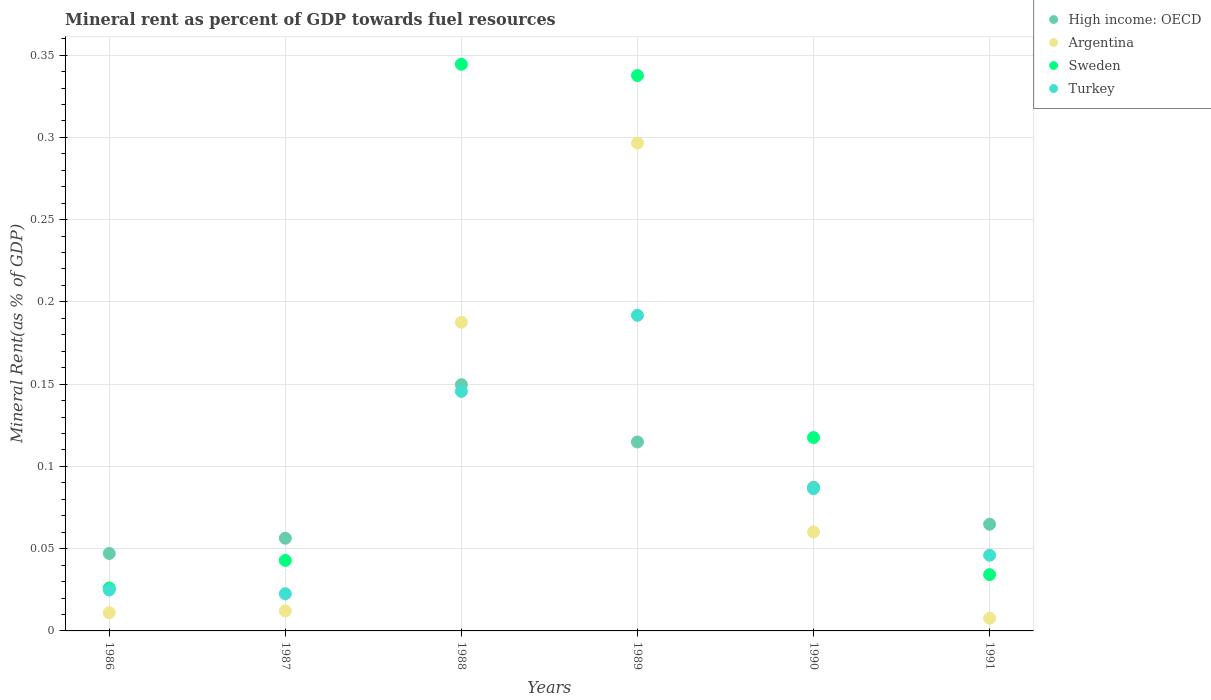What is the mineral rent in Turkey in 1990?
Your answer should be compact. 0.09. Across all years, what is the maximum mineral rent in Argentina?
Ensure brevity in your answer.  0.3. Across all years, what is the minimum mineral rent in Argentina?
Ensure brevity in your answer.  0.01. In which year was the mineral rent in High income: OECD maximum?
Offer a terse response. 1988. What is the total mineral rent in Argentina in the graph?
Ensure brevity in your answer.  0.58. What is the difference between the mineral rent in Sweden in 1990 and that in 1991?
Your answer should be compact. 0.08. What is the difference between the mineral rent in High income: OECD in 1990 and the mineral rent in Sweden in 1987?
Provide a succinct answer. 0.04. What is the average mineral rent in High income: OECD per year?
Keep it short and to the point. 0.09. In the year 1991, what is the difference between the mineral rent in Sweden and mineral rent in Turkey?
Make the answer very short. -0.01. In how many years, is the mineral rent in Argentina greater than 0.03 %?
Your answer should be compact. 3. What is the ratio of the mineral rent in Turkey in 1987 to that in 1989?
Offer a terse response. 0.12. Is the mineral rent in Argentina in 1986 less than that in 1989?
Offer a terse response. Yes. What is the difference between the highest and the second highest mineral rent in Turkey?
Make the answer very short. 0.05. What is the difference between the highest and the lowest mineral rent in Turkey?
Your answer should be compact. 0.17. In how many years, is the mineral rent in High income: OECD greater than the average mineral rent in High income: OECD taken over all years?
Provide a succinct answer. 3. Is the sum of the mineral rent in Turkey in 1987 and 1990 greater than the maximum mineral rent in High income: OECD across all years?
Your response must be concise. No. Is it the case that in every year, the sum of the mineral rent in Argentina and mineral rent in Turkey  is greater than the mineral rent in Sweden?
Provide a short and direct response. No. Does the mineral rent in High income: OECD monotonically increase over the years?
Offer a terse response. No. Is the mineral rent in High income: OECD strictly greater than the mineral rent in Sweden over the years?
Offer a very short reply. No. How many years are there in the graph?
Your answer should be compact. 6. Does the graph contain any zero values?
Provide a short and direct response. No. Does the graph contain grids?
Your answer should be compact. Yes. How are the legend labels stacked?
Your answer should be compact. Vertical. What is the title of the graph?
Provide a short and direct response. Mineral rent as percent of GDP towards fuel resources. What is the label or title of the X-axis?
Ensure brevity in your answer.  Years. What is the label or title of the Y-axis?
Provide a succinct answer. Mineral Rent(as % of GDP). What is the Mineral Rent(as % of GDP) of High income: OECD in 1986?
Your response must be concise. 0.05. What is the Mineral Rent(as % of GDP) of Argentina in 1986?
Make the answer very short. 0.01. What is the Mineral Rent(as % of GDP) in Sweden in 1986?
Give a very brief answer. 0.03. What is the Mineral Rent(as % of GDP) of Turkey in 1986?
Your answer should be compact. 0.02. What is the Mineral Rent(as % of GDP) in High income: OECD in 1987?
Your answer should be very brief. 0.06. What is the Mineral Rent(as % of GDP) of Argentina in 1987?
Make the answer very short. 0.01. What is the Mineral Rent(as % of GDP) in Sweden in 1987?
Provide a succinct answer. 0.04. What is the Mineral Rent(as % of GDP) of Turkey in 1987?
Offer a terse response. 0.02. What is the Mineral Rent(as % of GDP) in High income: OECD in 1988?
Ensure brevity in your answer.  0.15. What is the Mineral Rent(as % of GDP) of Argentina in 1988?
Give a very brief answer. 0.19. What is the Mineral Rent(as % of GDP) of Sweden in 1988?
Offer a very short reply. 0.34. What is the Mineral Rent(as % of GDP) in Turkey in 1988?
Give a very brief answer. 0.15. What is the Mineral Rent(as % of GDP) of High income: OECD in 1989?
Your response must be concise. 0.11. What is the Mineral Rent(as % of GDP) of Argentina in 1989?
Provide a short and direct response. 0.3. What is the Mineral Rent(as % of GDP) of Sweden in 1989?
Ensure brevity in your answer.  0.34. What is the Mineral Rent(as % of GDP) in Turkey in 1989?
Provide a succinct answer. 0.19. What is the Mineral Rent(as % of GDP) of High income: OECD in 1990?
Your response must be concise. 0.09. What is the Mineral Rent(as % of GDP) of Argentina in 1990?
Keep it short and to the point. 0.06. What is the Mineral Rent(as % of GDP) of Sweden in 1990?
Your answer should be compact. 0.12. What is the Mineral Rent(as % of GDP) in Turkey in 1990?
Provide a succinct answer. 0.09. What is the Mineral Rent(as % of GDP) in High income: OECD in 1991?
Keep it short and to the point. 0.06. What is the Mineral Rent(as % of GDP) of Argentina in 1991?
Your answer should be very brief. 0.01. What is the Mineral Rent(as % of GDP) of Sweden in 1991?
Provide a succinct answer. 0.03. What is the Mineral Rent(as % of GDP) in Turkey in 1991?
Your response must be concise. 0.05. Across all years, what is the maximum Mineral Rent(as % of GDP) in High income: OECD?
Make the answer very short. 0.15. Across all years, what is the maximum Mineral Rent(as % of GDP) of Argentina?
Make the answer very short. 0.3. Across all years, what is the maximum Mineral Rent(as % of GDP) in Sweden?
Your answer should be compact. 0.34. Across all years, what is the maximum Mineral Rent(as % of GDP) in Turkey?
Offer a terse response. 0.19. Across all years, what is the minimum Mineral Rent(as % of GDP) of High income: OECD?
Offer a very short reply. 0.05. Across all years, what is the minimum Mineral Rent(as % of GDP) in Argentina?
Provide a succinct answer. 0.01. Across all years, what is the minimum Mineral Rent(as % of GDP) in Sweden?
Give a very brief answer. 0.03. Across all years, what is the minimum Mineral Rent(as % of GDP) in Turkey?
Make the answer very short. 0.02. What is the total Mineral Rent(as % of GDP) in High income: OECD in the graph?
Provide a short and direct response. 0.52. What is the total Mineral Rent(as % of GDP) of Argentina in the graph?
Give a very brief answer. 0.58. What is the total Mineral Rent(as % of GDP) of Sweden in the graph?
Your answer should be compact. 0.9. What is the total Mineral Rent(as % of GDP) in Turkey in the graph?
Your answer should be very brief. 0.52. What is the difference between the Mineral Rent(as % of GDP) in High income: OECD in 1986 and that in 1987?
Offer a terse response. -0.01. What is the difference between the Mineral Rent(as % of GDP) of Argentina in 1986 and that in 1987?
Your response must be concise. -0. What is the difference between the Mineral Rent(as % of GDP) in Sweden in 1986 and that in 1987?
Your response must be concise. -0.02. What is the difference between the Mineral Rent(as % of GDP) in Turkey in 1986 and that in 1987?
Offer a very short reply. 0. What is the difference between the Mineral Rent(as % of GDP) in High income: OECD in 1986 and that in 1988?
Your answer should be compact. -0.1. What is the difference between the Mineral Rent(as % of GDP) in Argentina in 1986 and that in 1988?
Give a very brief answer. -0.18. What is the difference between the Mineral Rent(as % of GDP) in Sweden in 1986 and that in 1988?
Offer a terse response. -0.32. What is the difference between the Mineral Rent(as % of GDP) in Turkey in 1986 and that in 1988?
Make the answer very short. -0.12. What is the difference between the Mineral Rent(as % of GDP) of High income: OECD in 1986 and that in 1989?
Provide a short and direct response. -0.07. What is the difference between the Mineral Rent(as % of GDP) in Argentina in 1986 and that in 1989?
Make the answer very short. -0.29. What is the difference between the Mineral Rent(as % of GDP) of Sweden in 1986 and that in 1989?
Your answer should be compact. -0.31. What is the difference between the Mineral Rent(as % of GDP) in Turkey in 1986 and that in 1989?
Provide a short and direct response. -0.17. What is the difference between the Mineral Rent(as % of GDP) in High income: OECD in 1986 and that in 1990?
Ensure brevity in your answer.  -0.04. What is the difference between the Mineral Rent(as % of GDP) in Argentina in 1986 and that in 1990?
Offer a very short reply. -0.05. What is the difference between the Mineral Rent(as % of GDP) of Sweden in 1986 and that in 1990?
Ensure brevity in your answer.  -0.09. What is the difference between the Mineral Rent(as % of GDP) of Turkey in 1986 and that in 1990?
Offer a very short reply. -0.06. What is the difference between the Mineral Rent(as % of GDP) of High income: OECD in 1986 and that in 1991?
Keep it short and to the point. -0.02. What is the difference between the Mineral Rent(as % of GDP) of Argentina in 1986 and that in 1991?
Your answer should be very brief. 0. What is the difference between the Mineral Rent(as % of GDP) in Sweden in 1986 and that in 1991?
Your answer should be compact. -0.01. What is the difference between the Mineral Rent(as % of GDP) in Turkey in 1986 and that in 1991?
Offer a very short reply. -0.02. What is the difference between the Mineral Rent(as % of GDP) in High income: OECD in 1987 and that in 1988?
Offer a terse response. -0.09. What is the difference between the Mineral Rent(as % of GDP) in Argentina in 1987 and that in 1988?
Ensure brevity in your answer.  -0.18. What is the difference between the Mineral Rent(as % of GDP) of Sweden in 1987 and that in 1988?
Offer a very short reply. -0.3. What is the difference between the Mineral Rent(as % of GDP) in Turkey in 1987 and that in 1988?
Provide a short and direct response. -0.12. What is the difference between the Mineral Rent(as % of GDP) in High income: OECD in 1987 and that in 1989?
Provide a succinct answer. -0.06. What is the difference between the Mineral Rent(as % of GDP) in Argentina in 1987 and that in 1989?
Provide a short and direct response. -0.28. What is the difference between the Mineral Rent(as % of GDP) of Sweden in 1987 and that in 1989?
Your answer should be very brief. -0.29. What is the difference between the Mineral Rent(as % of GDP) of Turkey in 1987 and that in 1989?
Give a very brief answer. -0.17. What is the difference between the Mineral Rent(as % of GDP) in High income: OECD in 1987 and that in 1990?
Make the answer very short. -0.03. What is the difference between the Mineral Rent(as % of GDP) of Argentina in 1987 and that in 1990?
Your answer should be compact. -0.05. What is the difference between the Mineral Rent(as % of GDP) of Sweden in 1987 and that in 1990?
Your answer should be very brief. -0.07. What is the difference between the Mineral Rent(as % of GDP) in Turkey in 1987 and that in 1990?
Make the answer very short. -0.06. What is the difference between the Mineral Rent(as % of GDP) in High income: OECD in 1987 and that in 1991?
Provide a short and direct response. -0.01. What is the difference between the Mineral Rent(as % of GDP) of Argentina in 1987 and that in 1991?
Your answer should be very brief. 0. What is the difference between the Mineral Rent(as % of GDP) of Sweden in 1987 and that in 1991?
Make the answer very short. 0.01. What is the difference between the Mineral Rent(as % of GDP) of Turkey in 1987 and that in 1991?
Your answer should be very brief. -0.02. What is the difference between the Mineral Rent(as % of GDP) in High income: OECD in 1988 and that in 1989?
Provide a succinct answer. 0.03. What is the difference between the Mineral Rent(as % of GDP) of Argentina in 1988 and that in 1989?
Give a very brief answer. -0.11. What is the difference between the Mineral Rent(as % of GDP) in Sweden in 1988 and that in 1989?
Provide a succinct answer. 0.01. What is the difference between the Mineral Rent(as % of GDP) in Turkey in 1988 and that in 1989?
Your answer should be compact. -0.05. What is the difference between the Mineral Rent(as % of GDP) in High income: OECD in 1988 and that in 1990?
Offer a very short reply. 0.06. What is the difference between the Mineral Rent(as % of GDP) of Argentina in 1988 and that in 1990?
Your answer should be very brief. 0.13. What is the difference between the Mineral Rent(as % of GDP) in Sweden in 1988 and that in 1990?
Offer a terse response. 0.23. What is the difference between the Mineral Rent(as % of GDP) in Turkey in 1988 and that in 1990?
Provide a succinct answer. 0.06. What is the difference between the Mineral Rent(as % of GDP) in High income: OECD in 1988 and that in 1991?
Your answer should be very brief. 0.08. What is the difference between the Mineral Rent(as % of GDP) of Argentina in 1988 and that in 1991?
Your response must be concise. 0.18. What is the difference between the Mineral Rent(as % of GDP) in Sweden in 1988 and that in 1991?
Offer a very short reply. 0.31. What is the difference between the Mineral Rent(as % of GDP) of Turkey in 1988 and that in 1991?
Offer a terse response. 0.1. What is the difference between the Mineral Rent(as % of GDP) in High income: OECD in 1989 and that in 1990?
Ensure brevity in your answer.  0.03. What is the difference between the Mineral Rent(as % of GDP) of Argentina in 1989 and that in 1990?
Your answer should be very brief. 0.24. What is the difference between the Mineral Rent(as % of GDP) of Sweden in 1989 and that in 1990?
Give a very brief answer. 0.22. What is the difference between the Mineral Rent(as % of GDP) in Turkey in 1989 and that in 1990?
Offer a very short reply. 0.11. What is the difference between the Mineral Rent(as % of GDP) of High income: OECD in 1989 and that in 1991?
Provide a short and direct response. 0.05. What is the difference between the Mineral Rent(as % of GDP) of Argentina in 1989 and that in 1991?
Provide a succinct answer. 0.29. What is the difference between the Mineral Rent(as % of GDP) in Sweden in 1989 and that in 1991?
Offer a terse response. 0.3. What is the difference between the Mineral Rent(as % of GDP) of Turkey in 1989 and that in 1991?
Make the answer very short. 0.15. What is the difference between the Mineral Rent(as % of GDP) in High income: OECD in 1990 and that in 1991?
Keep it short and to the point. 0.02. What is the difference between the Mineral Rent(as % of GDP) in Argentina in 1990 and that in 1991?
Offer a terse response. 0.05. What is the difference between the Mineral Rent(as % of GDP) of Sweden in 1990 and that in 1991?
Ensure brevity in your answer.  0.08. What is the difference between the Mineral Rent(as % of GDP) in Turkey in 1990 and that in 1991?
Give a very brief answer. 0.04. What is the difference between the Mineral Rent(as % of GDP) in High income: OECD in 1986 and the Mineral Rent(as % of GDP) in Argentina in 1987?
Offer a terse response. 0.03. What is the difference between the Mineral Rent(as % of GDP) of High income: OECD in 1986 and the Mineral Rent(as % of GDP) of Sweden in 1987?
Give a very brief answer. 0. What is the difference between the Mineral Rent(as % of GDP) of High income: OECD in 1986 and the Mineral Rent(as % of GDP) of Turkey in 1987?
Keep it short and to the point. 0.02. What is the difference between the Mineral Rent(as % of GDP) of Argentina in 1986 and the Mineral Rent(as % of GDP) of Sweden in 1987?
Your response must be concise. -0.03. What is the difference between the Mineral Rent(as % of GDP) in Argentina in 1986 and the Mineral Rent(as % of GDP) in Turkey in 1987?
Give a very brief answer. -0.01. What is the difference between the Mineral Rent(as % of GDP) in Sweden in 1986 and the Mineral Rent(as % of GDP) in Turkey in 1987?
Your answer should be very brief. 0. What is the difference between the Mineral Rent(as % of GDP) in High income: OECD in 1986 and the Mineral Rent(as % of GDP) in Argentina in 1988?
Make the answer very short. -0.14. What is the difference between the Mineral Rent(as % of GDP) in High income: OECD in 1986 and the Mineral Rent(as % of GDP) in Sweden in 1988?
Your answer should be compact. -0.3. What is the difference between the Mineral Rent(as % of GDP) in High income: OECD in 1986 and the Mineral Rent(as % of GDP) in Turkey in 1988?
Your answer should be compact. -0.1. What is the difference between the Mineral Rent(as % of GDP) in Argentina in 1986 and the Mineral Rent(as % of GDP) in Sweden in 1988?
Your response must be concise. -0.33. What is the difference between the Mineral Rent(as % of GDP) in Argentina in 1986 and the Mineral Rent(as % of GDP) in Turkey in 1988?
Provide a short and direct response. -0.13. What is the difference between the Mineral Rent(as % of GDP) in Sweden in 1986 and the Mineral Rent(as % of GDP) in Turkey in 1988?
Give a very brief answer. -0.12. What is the difference between the Mineral Rent(as % of GDP) in High income: OECD in 1986 and the Mineral Rent(as % of GDP) in Argentina in 1989?
Offer a very short reply. -0.25. What is the difference between the Mineral Rent(as % of GDP) of High income: OECD in 1986 and the Mineral Rent(as % of GDP) of Sweden in 1989?
Provide a succinct answer. -0.29. What is the difference between the Mineral Rent(as % of GDP) in High income: OECD in 1986 and the Mineral Rent(as % of GDP) in Turkey in 1989?
Give a very brief answer. -0.14. What is the difference between the Mineral Rent(as % of GDP) in Argentina in 1986 and the Mineral Rent(as % of GDP) in Sweden in 1989?
Your answer should be very brief. -0.33. What is the difference between the Mineral Rent(as % of GDP) in Argentina in 1986 and the Mineral Rent(as % of GDP) in Turkey in 1989?
Keep it short and to the point. -0.18. What is the difference between the Mineral Rent(as % of GDP) of Sweden in 1986 and the Mineral Rent(as % of GDP) of Turkey in 1989?
Keep it short and to the point. -0.17. What is the difference between the Mineral Rent(as % of GDP) in High income: OECD in 1986 and the Mineral Rent(as % of GDP) in Argentina in 1990?
Ensure brevity in your answer.  -0.01. What is the difference between the Mineral Rent(as % of GDP) of High income: OECD in 1986 and the Mineral Rent(as % of GDP) of Sweden in 1990?
Give a very brief answer. -0.07. What is the difference between the Mineral Rent(as % of GDP) of High income: OECD in 1986 and the Mineral Rent(as % of GDP) of Turkey in 1990?
Your response must be concise. -0.04. What is the difference between the Mineral Rent(as % of GDP) in Argentina in 1986 and the Mineral Rent(as % of GDP) in Sweden in 1990?
Your response must be concise. -0.11. What is the difference between the Mineral Rent(as % of GDP) in Argentina in 1986 and the Mineral Rent(as % of GDP) in Turkey in 1990?
Make the answer very short. -0.08. What is the difference between the Mineral Rent(as % of GDP) of Sweden in 1986 and the Mineral Rent(as % of GDP) of Turkey in 1990?
Offer a very short reply. -0.06. What is the difference between the Mineral Rent(as % of GDP) of High income: OECD in 1986 and the Mineral Rent(as % of GDP) of Argentina in 1991?
Give a very brief answer. 0.04. What is the difference between the Mineral Rent(as % of GDP) in High income: OECD in 1986 and the Mineral Rent(as % of GDP) in Sweden in 1991?
Offer a very short reply. 0.01. What is the difference between the Mineral Rent(as % of GDP) of High income: OECD in 1986 and the Mineral Rent(as % of GDP) of Turkey in 1991?
Ensure brevity in your answer.  0. What is the difference between the Mineral Rent(as % of GDP) of Argentina in 1986 and the Mineral Rent(as % of GDP) of Sweden in 1991?
Provide a succinct answer. -0.02. What is the difference between the Mineral Rent(as % of GDP) of Argentina in 1986 and the Mineral Rent(as % of GDP) of Turkey in 1991?
Keep it short and to the point. -0.03. What is the difference between the Mineral Rent(as % of GDP) of Sweden in 1986 and the Mineral Rent(as % of GDP) of Turkey in 1991?
Make the answer very short. -0.02. What is the difference between the Mineral Rent(as % of GDP) of High income: OECD in 1987 and the Mineral Rent(as % of GDP) of Argentina in 1988?
Your response must be concise. -0.13. What is the difference between the Mineral Rent(as % of GDP) of High income: OECD in 1987 and the Mineral Rent(as % of GDP) of Sweden in 1988?
Your answer should be compact. -0.29. What is the difference between the Mineral Rent(as % of GDP) in High income: OECD in 1987 and the Mineral Rent(as % of GDP) in Turkey in 1988?
Your response must be concise. -0.09. What is the difference between the Mineral Rent(as % of GDP) in Argentina in 1987 and the Mineral Rent(as % of GDP) in Sweden in 1988?
Offer a terse response. -0.33. What is the difference between the Mineral Rent(as % of GDP) in Argentina in 1987 and the Mineral Rent(as % of GDP) in Turkey in 1988?
Offer a terse response. -0.13. What is the difference between the Mineral Rent(as % of GDP) in Sweden in 1987 and the Mineral Rent(as % of GDP) in Turkey in 1988?
Provide a succinct answer. -0.1. What is the difference between the Mineral Rent(as % of GDP) in High income: OECD in 1987 and the Mineral Rent(as % of GDP) in Argentina in 1989?
Keep it short and to the point. -0.24. What is the difference between the Mineral Rent(as % of GDP) in High income: OECD in 1987 and the Mineral Rent(as % of GDP) in Sweden in 1989?
Give a very brief answer. -0.28. What is the difference between the Mineral Rent(as % of GDP) of High income: OECD in 1987 and the Mineral Rent(as % of GDP) of Turkey in 1989?
Keep it short and to the point. -0.14. What is the difference between the Mineral Rent(as % of GDP) in Argentina in 1987 and the Mineral Rent(as % of GDP) in Sweden in 1989?
Make the answer very short. -0.33. What is the difference between the Mineral Rent(as % of GDP) of Argentina in 1987 and the Mineral Rent(as % of GDP) of Turkey in 1989?
Your response must be concise. -0.18. What is the difference between the Mineral Rent(as % of GDP) of Sweden in 1987 and the Mineral Rent(as % of GDP) of Turkey in 1989?
Your answer should be very brief. -0.15. What is the difference between the Mineral Rent(as % of GDP) of High income: OECD in 1987 and the Mineral Rent(as % of GDP) of Argentina in 1990?
Ensure brevity in your answer.  -0. What is the difference between the Mineral Rent(as % of GDP) of High income: OECD in 1987 and the Mineral Rent(as % of GDP) of Sweden in 1990?
Your response must be concise. -0.06. What is the difference between the Mineral Rent(as % of GDP) in High income: OECD in 1987 and the Mineral Rent(as % of GDP) in Turkey in 1990?
Give a very brief answer. -0.03. What is the difference between the Mineral Rent(as % of GDP) in Argentina in 1987 and the Mineral Rent(as % of GDP) in Sweden in 1990?
Give a very brief answer. -0.11. What is the difference between the Mineral Rent(as % of GDP) of Argentina in 1987 and the Mineral Rent(as % of GDP) of Turkey in 1990?
Your answer should be compact. -0.07. What is the difference between the Mineral Rent(as % of GDP) in Sweden in 1987 and the Mineral Rent(as % of GDP) in Turkey in 1990?
Ensure brevity in your answer.  -0.04. What is the difference between the Mineral Rent(as % of GDP) of High income: OECD in 1987 and the Mineral Rent(as % of GDP) of Argentina in 1991?
Your response must be concise. 0.05. What is the difference between the Mineral Rent(as % of GDP) of High income: OECD in 1987 and the Mineral Rent(as % of GDP) of Sweden in 1991?
Offer a very short reply. 0.02. What is the difference between the Mineral Rent(as % of GDP) of High income: OECD in 1987 and the Mineral Rent(as % of GDP) of Turkey in 1991?
Your response must be concise. 0.01. What is the difference between the Mineral Rent(as % of GDP) of Argentina in 1987 and the Mineral Rent(as % of GDP) of Sweden in 1991?
Keep it short and to the point. -0.02. What is the difference between the Mineral Rent(as % of GDP) of Argentina in 1987 and the Mineral Rent(as % of GDP) of Turkey in 1991?
Your response must be concise. -0.03. What is the difference between the Mineral Rent(as % of GDP) in Sweden in 1987 and the Mineral Rent(as % of GDP) in Turkey in 1991?
Provide a short and direct response. -0. What is the difference between the Mineral Rent(as % of GDP) in High income: OECD in 1988 and the Mineral Rent(as % of GDP) in Argentina in 1989?
Offer a terse response. -0.15. What is the difference between the Mineral Rent(as % of GDP) in High income: OECD in 1988 and the Mineral Rent(as % of GDP) in Sweden in 1989?
Your answer should be very brief. -0.19. What is the difference between the Mineral Rent(as % of GDP) of High income: OECD in 1988 and the Mineral Rent(as % of GDP) of Turkey in 1989?
Your response must be concise. -0.04. What is the difference between the Mineral Rent(as % of GDP) in Argentina in 1988 and the Mineral Rent(as % of GDP) in Turkey in 1989?
Your answer should be very brief. -0. What is the difference between the Mineral Rent(as % of GDP) of Sweden in 1988 and the Mineral Rent(as % of GDP) of Turkey in 1989?
Offer a very short reply. 0.15. What is the difference between the Mineral Rent(as % of GDP) in High income: OECD in 1988 and the Mineral Rent(as % of GDP) in Argentina in 1990?
Your answer should be very brief. 0.09. What is the difference between the Mineral Rent(as % of GDP) in High income: OECD in 1988 and the Mineral Rent(as % of GDP) in Sweden in 1990?
Ensure brevity in your answer.  0.03. What is the difference between the Mineral Rent(as % of GDP) of High income: OECD in 1988 and the Mineral Rent(as % of GDP) of Turkey in 1990?
Make the answer very short. 0.06. What is the difference between the Mineral Rent(as % of GDP) of Argentina in 1988 and the Mineral Rent(as % of GDP) of Sweden in 1990?
Provide a succinct answer. 0.07. What is the difference between the Mineral Rent(as % of GDP) of Argentina in 1988 and the Mineral Rent(as % of GDP) of Turkey in 1990?
Your response must be concise. 0.1. What is the difference between the Mineral Rent(as % of GDP) in Sweden in 1988 and the Mineral Rent(as % of GDP) in Turkey in 1990?
Ensure brevity in your answer.  0.26. What is the difference between the Mineral Rent(as % of GDP) in High income: OECD in 1988 and the Mineral Rent(as % of GDP) in Argentina in 1991?
Your answer should be compact. 0.14. What is the difference between the Mineral Rent(as % of GDP) of High income: OECD in 1988 and the Mineral Rent(as % of GDP) of Sweden in 1991?
Offer a very short reply. 0.12. What is the difference between the Mineral Rent(as % of GDP) of High income: OECD in 1988 and the Mineral Rent(as % of GDP) of Turkey in 1991?
Your response must be concise. 0.1. What is the difference between the Mineral Rent(as % of GDP) of Argentina in 1988 and the Mineral Rent(as % of GDP) of Sweden in 1991?
Provide a succinct answer. 0.15. What is the difference between the Mineral Rent(as % of GDP) of Argentina in 1988 and the Mineral Rent(as % of GDP) of Turkey in 1991?
Provide a short and direct response. 0.14. What is the difference between the Mineral Rent(as % of GDP) in Sweden in 1988 and the Mineral Rent(as % of GDP) in Turkey in 1991?
Your response must be concise. 0.3. What is the difference between the Mineral Rent(as % of GDP) in High income: OECD in 1989 and the Mineral Rent(as % of GDP) in Argentina in 1990?
Offer a terse response. 0.05. What is the difference between the Mineral Rent(as % of GDP) of High income: OECD in 1989 and the Mineral Rent(as % of GDP) of Sweden in 1990?
Provide a succinct answer. -0. What is the difference between the Mineral Rent(as % of GDP) in High income: OECD in 1989 and the Mineral Rent(as % of GDP) in Turkey in 1990?
Offer a very short reply. 0.03. What is the difference between the Mineral Rent(as % of GDP) of Argentina in 1989 and the Mineral Rent(as % of GDP) of Sweden in 1990?
Offer a terse response. 0.18. What is the difference between the Mineral Rent(as % of GDP) of Argentina in 1989 and the Mineral Rent(as % of GDP) of Turkey in 1990?
Your answer should be very brief. 0.21. What is the difference between the Mineral Rent(as % of GDP) in Sweden in 1989 and the Mineral Rent(as % of GDP) in Turkey in 1990?
Your answer should be compact. 0.25. What is the difference between the Mineral Rent(as % of GDP) in High income: OECD in 1989 and the Mineral Rent(as % of GDP) in Argentina in 1991?
Offer a terse response. 0.11. What is the difference between the Mineral Rent(as % of GDP) in High income: OECD in 1989 and the Mineral Rent(as % of GDP) in Sweden in 1991?
Make the answer very short. 0.08. What is the difference between the Mineral Rent(as % of GDP) of High income: OECD in 1989 and the Mineral Rent(as % of GDP) of Turkey in 1991?
Provide a succinct answer. 0.07. What is the difference between the Mineral Rent(as % of GDP) in Argentina in 1989 and the Mineral Rent(as % of GDP) in Sweden in 1991?
Provide a succinct answer. 0.26. What is the difference between the Mineral Rent(as % of GDP) of Argentina in 1989 and the Mineral Rent(as % of GDP) of Turkey in 1991?
Give a very brief answer. 0.25. What is the difference between the Mineral Rent(as % of GDP) in Sweden in 1989 and the Mineral Rent(as % of GDP) in Turkey in 1991?
Your answer should be compact. 0.29. What is the difference between the Mineral Rent(as % of GDP) in High income: OECD in 1990 and the Mineral Rent(as % of GDP) in Argentina in 1991?
Your response must be concise. 0.08. What is the difference between the Mineral Rent(as % of GDP) of High income: OECD in 1990 and the Mineral Rent(as % of GDP) of Sweden in 1991?
Offer a very short reply. 0.05. What is the difference between the Mineral Rent(as % of GDP) in High income: OECD in 1990 and the Mineral Rent(as % of GDP) in Turkey in 1991?
Your answer should be compact. 0.04. What is the difference between the Mineral Rent(as % of GDP) of Argentina in 1990 and the Mineral Rent(as % of GDP) of Sweden in 1991?
Give a very brief answer. 0.03. What is the difference between the Mineral Rent(as % of GDP) in Argentina in 1990 and the Mineral Rent(as % of GDP) in Turkey in 1991?
Your response must be concise. 0.01. What is the difference between the Mineral Rent(as % of GDP) in Sweden in 1990 and the Mineral Rent(as % of GDP) in Turkey in 1991?
Your answer should be very brief. 0.07. What is the average Mineral Rent(as % of GDP) in High income: OECD per year?
Keep it short and to the point. 0.09. What is the average Mineral Rent(as % of GDP) in Argentina per year?
Provide a succinct answer. 0.1. What is the average Mineral Rent(as % of GDP) in Sweden per year?
Your answer should be compact. 0.15. What is the average Mineral Rent(as % of GDP) in Turkey per year?
Your answer should be compact. 0.09. In the year 1986, what is the difference between the Mineral Rent(as % of GDP) in High income: OECD and Mineral Rent(as % of GDP) in Argentina?
Keep it short and to the point. 0.04. In the year 1986, what is the difference between the Mineral Rent(as % of GDP) of High income: OECD and Mineral Rent(as % of GDP) of Sweden?
Offer a very short reply. 0.02. In the year 1986, what is the difference between the Mineral Rent(as % of GDP) of High income: OECD and Mineral Rent(as % of GDP) of Turkey?
Your answer should be compact. 0.02. In the year 1986, what is the difference between the Mineral Rent(as % of GDP) of Argentina and Mineral Rent(as % of GDP) of Sweden?
Offer a terse response. -0.01. In the year 1986, what is the difference between the Mineral Rent(as % of GDP) of Argentina and Mineral Rent(as % of GDP) of Turkey?
Offer a very short reply. -0.01. In the year 1986, what is the difference between the Mineral Rent(as % of GDP) of Sweden and Mineral Rent(as % of GDP) of Turkey?
Your response must be concise. 0. In the year 1987, what is the difference between the Mineral Rent(as % of GDP) in High income: OECD and Mineral Rent(as % of GDP) in Argentina?
Ensure brevity in your answer.  0.04. In the year 1987, what is the difference between the Mineral Rent(as % of GDP) in High income: OECD and Mineral Rent(as % of GDP) in Sweden?
Give a very brief answer. 0.01. In the year 1987, what is the difference between the Mineral Rent(as % of GDP) in High income: OECD and Mineral Rent(as % of GDP) in Turkey?
Keep it short and to the point. 0.03. In the year 1987, what is the difference between the Mineral Rent(as % of GDP) in Argentina and Mineral Rent(as % of GDP) in Sweden?
Your answer should be compact. -0.03. In the year 1987, what is the difference between the Mineral Rent(as % of GDP) in Argentina and Mineral Rent(as % of GDP) in Turkey?
Your answer should be very brief. -0.01. In the year 1987, what is the difference between the Mineral Rent(as % of GDP) of Sweden and Mineral Rent(as % of GDP) of Turkey?
Your answer should be compact. 0.02. In the year 1988, what is the difference between the Mineral Rent(as % of GDP) in High income: OECD and Mineral Rent(as % of GDP) in Argentina?
Offer a terse response. -0.04. In the year 1988, what is the difference between the Mineral Rent(as % of GDP) in High income: OECD and Mineral Rent(as % of GDP) in Sweden?
Make the answer very short. -0.19. In the year 1988, what is the difference between the Mineral Rent(as % of GDP) in High income: OECD and Mineral Rent(as % of GDP) in Turkey?
Provide a succinct answer. 0. In the year 1988, what is the difference between the Mineral Rent(as % of GDP) in Argentina and Mineral Rent(as % of GDP) in Sweden?
Your response must be concise. -0.16. In the year 1988, what is the difference between the Mineral Rent(as % of GDP) of Argentina and Mineral Rent(as % of GDP) of Turkey?
Your response must be concise. 0.04. In the year 1988, what is the difference between the Mineral Rent(as % of GDP) of Sweden and Mineral Rent(as % of GDP) of Turkey?
Provide a succinct answer. 0.2. In the year 1989, what is the difference between the Mineral Rent(as % of GDP) in High income: OECD and Mineral Rent(as % of GDP) in Argentina?
Your answer should be very brief. -0.18. In the year 1989, what is the difference between the Mineral Rent(as % of GDP) of High income: OECD and Mineral Rent(as % of GDP) of Sweden?
Offer a very short reply. -0.22. In the year 1989, what is the difference between the Mineral Rent(as % of GDP) in High income: OECD and Mineral Rent(as % of GDP) in Turkey?
Give a very brief answer. -0.08. In the year 1989, what is the difference between the Mineral Rent(as % of GDP) in Argentina and Mineral Rent(as % of GDP) in Sweden?
Give a very brief answer. -0.04. In the year 1989, what is the difference between the Mineral Rent(as % of GDP) of Argentina and Mineral Rent(as % of GDP) of Turkey?
Make the answer very short. 0.1. In the year 1989, what is the difference between the Mineral Rent(as % of GDP) of Sweden and Mineral Rent(as % of GDP) of Turkey?
Offer a terse response. 0.15. In the year 1990, what is the difference between the Mineral Rent(as % of GDP) in High income: OECD and Mineral Rent(as % of GDP) in Argentina?
Keep it short and to the point. 0.03. In the year 1990, what is the difference between the Mineral Rent(as % of GDP) in High income: OECD and Mineral Rent(as % of GDP) in Sweden?
Your answer should be very brief. -0.03. In the year 1990, what is the difference between the Mineral Rent(as % of GDP) of High income: OECD and Mineral Rent(as % of GDP) of Turkey?
Offer a terse response. 0. In the year 1990, what is the difference between the Mineral Rent(as % of GDP) of Argentina and Mineral Rent(as % of GDP) of Sweden?
Provide a succinct answer. -0.06. In the year 1990, what is the difference between the Mineral Rent(as % of GDP) of Argentina and Mineral Rent(as % of GDP) of Turkey?
Your answer should be very brief. -0.03. In the year 1990, what is the difference between the Mineral Rent(as % of GDP) of Sweden and Mineral Rent(as % of GDP) of Turkey?
Your answer should be compact. 0.03. In the year 1991, what is the difference between the Mineral Rent(as % of GDP) in High income: OECD and Mineral Rent(as % of GDP) in Argentina?
Give a very brief answer. 0.06. In the year 1991, what is the difference between the Mineral Rent(as % of GDP) of High income: OECD and Mineral Rent(as % of GDP) of Sweden?
Your answer should be very brief. 0.03. In the year 1991, what is the difference between the Mineral Rent(as % of GDP) in High income: OECD and Mineral Rent(as % of GDP) in Turkey?
Offer a very short reply. 0.02. In the year 1991, what is the difference between the Mineral Rent(as % of GDP) in Argentina and Mineral Rent(as % of GDP) in Sweden?
Offer a very short reply. -0.03. In the year 1991, what is the difference between the Mineral Rent(as % of GDP) of Argentina and Mineral Rent(as % of GDP) of Turkey?
Ensure brevity in your answer.  -0.04. In the year 1991, what is the difference between the Mineral Rent(as % of GDP) in Sweden and Mineral Rent(as % of GDP) in Turkey?
Your response must be concise. -0.01. What is the ratio of the Mineral Rent(as % of GDP) of High income: OECD in 1986 to that in 1987?
Offer a very short reply. 0.84. What is the ratio of the Mineral Rent(as % of GDP) in Argentina in 1986 to that in 1987?
Your response must be concise. 0.91. What is the ratio of the Mineral Rent(as % of GDP) of Sweden in 1986 to that in 1987?
Your response must be concise. 0.61. What is the ratio of the Mineral Rent(as % of GDP) in Turkey in 1986 to that in 1987?
Your answer should be compact. 1.1. What is the ratio of the Mineral Rent(as % of GDP) of High income: OECD in 1986 to that in 1988?
Ensure brevity in your answer.  0.31. What is the ratio of the Mineral Rent(as % of GDP) of Argentina in 1986 to that in 1988?
Provide a succinct answer. 0.06. What is the ratio of the Mineral Rent(as % of GDP) in Sweden in 1986 to that in 1988?
Your answer should be compact. 0.08. What is the ratio of the Mineral Rent(as % of GDP) in Turkey in 1986 to that in 1988?
Your answer should be very brief. 0.17. What is the ratio of the Mineral Rent(as % of GDP) in High income: OECD in 1986 to that in 1989?
Offer a terse response. 0.41. What is the ratio of the Mineral Rent(as % of GDP) of Argentina in 1986 to that in 1989?
Keep it short and to the point. 0.04. What is the ratio of the Mineral Rent(as % of GDP) in Sweden in 1986 to that in 1989?
Offer a very short reply. 0.08. What is the ratio of the Mineral Rent(as % of GDP) in Turkey in 1986 to that in 1989?
Offer a terse response. 0.13. What is the ratio of the Mineral Rent(as % of GDP) of High income: OECD in 1986 to that in 1990?
Ensure brevity in your answer.  0.54. What is the ratio of the Mineral Rent(as % of GDP) in Argentina in 1986 to that in 1990?
Provide a short and direct response. 0.18. What is the ratio of the Mineral Rent(as % of GDP) of Sweden in 1986 to that in 1990?
Give a very brief answer. 0.22. What is the ratio of the Mineral Rent(as % of GDP) of Turkey in 1986 to that in 1990?
Make the answer very short. 0.29. What is the ratio of the Mineral Rent(as % of GDP) in High income: OECD in 1986 to that in 1991?
Provide a succinct answer. 0.73. What is the ratio of the Mineral Rent(as % of GDP) of Argentina in 1986 to that in 1991?
Make the answer very short. 1.44. What is the ratio of the Mineral Rent(as % of GDP) in Sweden in 1986 to that in 1991?
Provide a short and direct response. 0.76. What is the ratio of the Mineral Rent(as % of GDP) of Turkey in 1986 to that in 1991?
Give a very brief answer. 0.54. What is the ratio of the Mineral Rent(as % of GDP) of High income: OECD in 1987 to that in 1988?
Offer a very short reply. 0.38. What is the ratio of the Mineral Rent(as % of GDP) in Argentina in 1987 to that in 1988?
Your response must be concise. 0.06. What is the ratio of the Mineral Rent(as % of GDP) in Sweden in 1987 to that in 1988?
Offer a terse response. 0.12. What is the ratio of the Mineral Rent(as % of GDP) in Turkey in 1987 to that in 1988?
Your answer should be compact. 0.16. What is the ratio of the Mineral Rent(as % of GDP) in High income: OECD in 1987 to that in 1989?
Give a very brief answer. 0.49. What is the ratio of the Mineral Rent(as % of GDP) of Argentina in 1987 to that in 1989?
Keep it short and to the point. 0.04. What is the ratio of the Mineral Rent(as % of GDP) in Sweden in 1987 to that in 1989?
Offer a terse response. 0.13. What is the ratio of the Mineral Rent(as % of GDP) of Turkey in 1987 to that in 1989?
Provide a short and direct response. 0.12. What is the ratio of the Mineral Rent(as % of GDP) in High income: OECD in 1987 to that in 1990?
Your answer should be very brief. 0.65. What is the ratio of the Mineral Rent(as % of GDP) in Argentina in 1987 to that in 1990?
Provide a succinct answer. 0.2. What is the ratio of the Mineral Rent(as % of GDP) in Sweden in 1987 to that in 1990?
Your response must be concise. 0.36. What is the ratio of the Mineral Rent(as % of GDP) of Turkey in 1987 to that in 1990?
Your response must be concise. 0.26. What is the ratio of the Mineral Rent(as % of GDP) in High income: OECD in 1987 to that in 1991?
Provide a short and direct response. 0.87. What is the ratio of the Mineral Rent(as % of GDP) of Argentina in 1987 to that in 1991?
Your answer should be very brief. 1.58. What is the ratio of the Mineral Rent(as % of GDP) of Sweden in 1987 to that in 1991?
Make the answer very short. 1.25. What is the ratio of the Mineral Rent(as % of GDP) in Turkey in 1987 to that in 1991?
Provide a succinct answer. 0.49. What is the ratio of the Mineral Rent(as % of GDP) of High income: OECD in 1988 to that in 1989?
Your response must be concise. 1.3. What is the ratio of the Mineral Rent(as % of GDP) in Argentina in 1988 to that in 1989?
Your answer should be compact. 0.63. What is the ratio of the Mineral Rent(as % of GDP) in Sweden in 1988 to that in 1989?
Your answer should be very brief. 1.02. What is the ratio of the Mineral Rent(as % of GDP) in Turkey in 1988 to that in 1989?
Keep it short and to the point. 0.76. What is the ratio of the Mineral Rent(as % of GDP) of High income: OECD in 1988 to that in 1990?
Ensure brevity in your answer.  1.71. What is the ratio of the Mineral Rent(as % of GDP) of Argentina in 1988 to that in 1990?
Offer a terse response. 3.12. What is the ratio of the Mineral Rent(as % of GDP) in Sweden in 1988 to that in 1990?
Keep it short and to the point. 2.93. What is the ratio of the Mineral Rent(as % of GDP) in Turkey in 1988 to that in 1990?
Provide a short and direct response. 1.68. What is the ratio of the Mineral Rent(as % of GDP) of High income: OECD in 1988 to that in 1991?
Provide a succinct answer. 2.31. What is the ratio of the Mineral Rent(as % of GDP) in Argentina in 1988 to that in 1991?
Offer a very short reply. 24.41. What is the ratio of the Mineral Rent(as % of GDP) in Sweden in 1988 to that in 1991?
Provide a short and direct response. 10.07. What is the ratio of the Mineral Rent(as % of GDP) of Turkey in 1988 to that in 1991?
Offer a very short reply. 3.17. What is the ratio of the Mineral Rent(as % of GDP) in High income: OECD in 1989 to that in 1990?
Your answer should be very brief. 1.32. What is the ratio of the Mineral Rent(as % of GDP) of Argentina in 1989 to that in 1990?
Keep it short and to the point. 4.93. What is the ratio of the Mineral Rent(as % of GDP) in Sweden in 1989 to that in 1990?
Your answer should be compact. 2.87. What is the ratio of the Mineral Rent(as % of GDP) of Turkey in 1989 to that in 1990?
Your answer should be very brief. 2.22. What is the ratio of the Mineral Rent(as % of GDP) of High income: OECD in 1989 to that in 1991?
Your answer should be very brief. 1.77. What is the ratio of the Mineral Rent(as % of GDP) of Argentina in 1989 to that in 1991?
Offer a terse response. 38.58. What is the ratio of the Mineral Rent(as % of GDP) of Sweden in 1989 to that in 1991?
Offer a terse response. 9.87. What is the ratio of the Mineral Rent(as % of GDP) in Turkey in 1989 to that in 1991?
Offer a very short reply. 4.17. What is the ratio of the Mineral Rent(as % of GDP) of High income: OECD in 1990 to that in 1991?
Provide a short and direct response. 1.35. What is the ratio of the Mineral Rent(as % of GDP) of Argentina in 1990 to that in 1991?
Ensure brevity in your answer.  7.82. What is the ratio of the Mineral Rent(as % of GDP) in Sweden in 1990 to that in 1991?
Offer a very short reply. 3.43. What is the ratio of the Mineral Rent(as % of GDP) of Turkey in 1990 to that in 1991?
Give a very brief answer. 1.88. What is the difference between the highest and the second highest Mineral Rent(as % of GDP) in High income: OECD?
Ensure brevity in your answer.  0.03. What is the difference between the highest and the second highest Mineral Rent(as % of GDP) of Argentina?
Provide a succinct answer. 0.11. What is the difference between the highest and the second highest Mineral Rent(as % of GDP) of Sweden?
Make the answer very short. 0.01. What is the difference between the highest and the second highest Mineral Rent(as % of GDP) in Turkey?
Ensure brevity in your answer.  0.05. What is the difference between the highest and the lowest Mineral Rent(as % of GDP) of High income: OECD?
Your answer should be very brief. 0.1. What is the difference between the highest and the lowest Mineral Rent(as % of GDP) of Argentina?
Provide a succinct answer. 0.29. What is the difference between the highest and the lowest Mineral Rent(as % of GDP) in Sweden?
Offer a very short reply. 0.32. What is the difference between the highest and the lowest Mineral Rent(as % of GDP) in Turkey?
Ensure brevity in your answer.  0.17. 